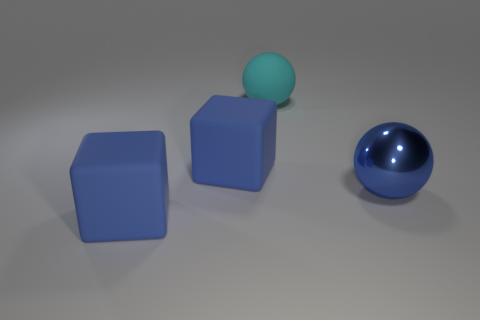Subtract all cyan spheres. How many spheres are left? 1 Add 3 blue things. How many objects exist? 7 Subtract all purple blocks. Subtract all purple cylinders. How many blocks are left? 2 Subtract all rubber balls. Subtract all tiny blue shiny cylinders. How many objects are left? 3 Add 4 big blue cubes. How many big blue cubes are left? 6 Add 3 cyan spheres. How many cyan spheres exist? 4 Subtract 0 gray cubes. How many objects are left? 4 